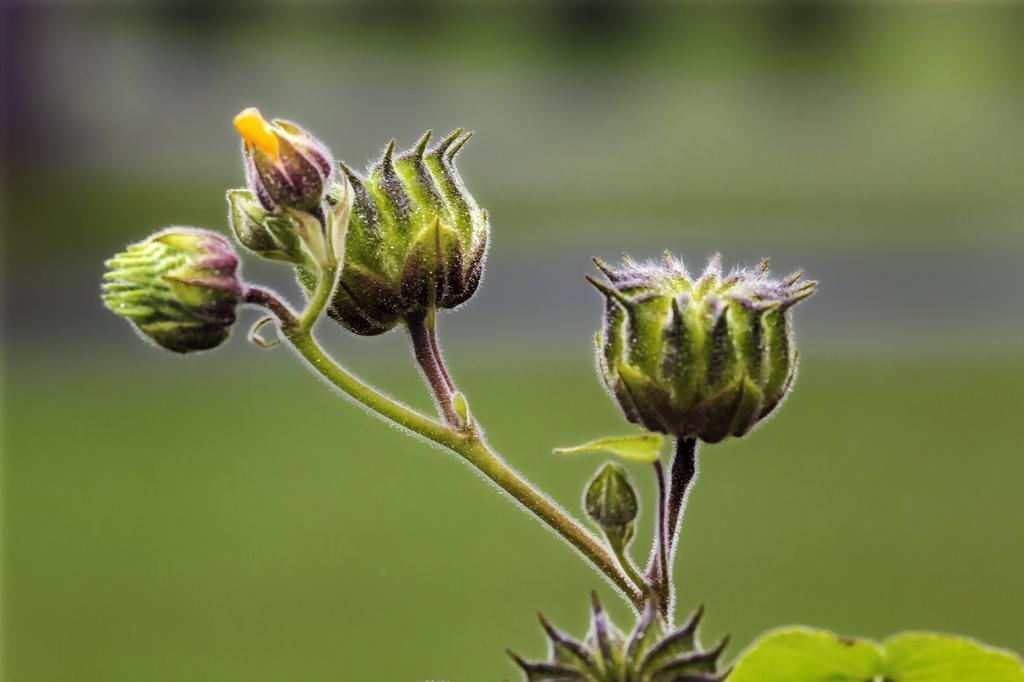What type of plant is visible in the image? There is a plant with buds in the image. Can you describe the background of the image? The background of the image is blurry. What type of mine can be seen in the image? There is no mine present in the image; it features a plant with buds and a blurry background. 